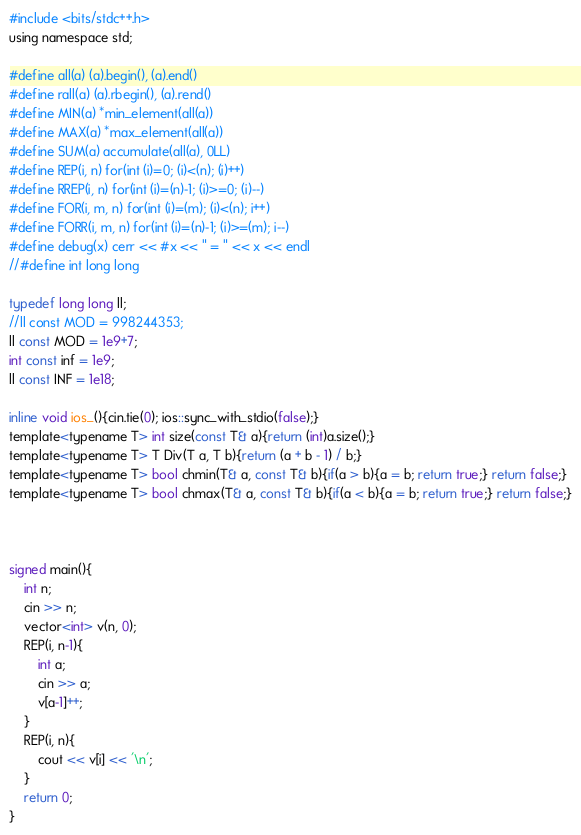Convert code to text. <code><loc_0><loc_0><loc_500><loc_500><_C_>#include <bits/stdc++.h>
using namespace std;

#define all(a) (a).begin(), (a).end()
#define rall(a) (a).rbegin(), (a).rend()
#define MIN(a) *min_element(all(a))
#define MAX(a) *max_element(all(a))
#define SUM(a) accumulate(all(a), 0LL)
#define REP(i, n) for(int (i)=0; (i)<(n); (i)++)
#define RREP(i, n) for(int (i)=(n)-1; (i)>=0; (i)--)
#define FOR(i, m, n) for(int (i)=(m); (i)<(n); i++)
#define FORR(i, m, n) for(int (i)=(n)-1; (i)>=(m); i--)
#define debug(x) cerr << #x << " = " << x << endl
//#define int long long

typedef long long ll;
//ll const MOD = 998244353;
ll const MOD = 1e9+7;
int const inf = 1e9;
ll const INF = 1e18;

inline void ios_(){cin.tie(0); ios::sync_with_stdio(false);}
template<typename T> int size(const T& a){return (int)a.size();}
template<typename T> T Div(T a, T b){return (a + b - 1) / b;}
template<typename T> bool chmin(T& a, const T& b){if(a > b){a = b; return true;} return false;}
template<typename T> bool chmax(T& a, const T& b){if(a < b){a = b; return true;} return false;}



signed main(){
    int n;
    cin >> n;
    vector<int> v(n, 0);
    REP(i, n-1){
        int a;
        cin >> a;
        v[a-1]++;
    }
    REP(i, n){
        cout << v[i] << '\n';
    }
    return 0;
}
</code> 